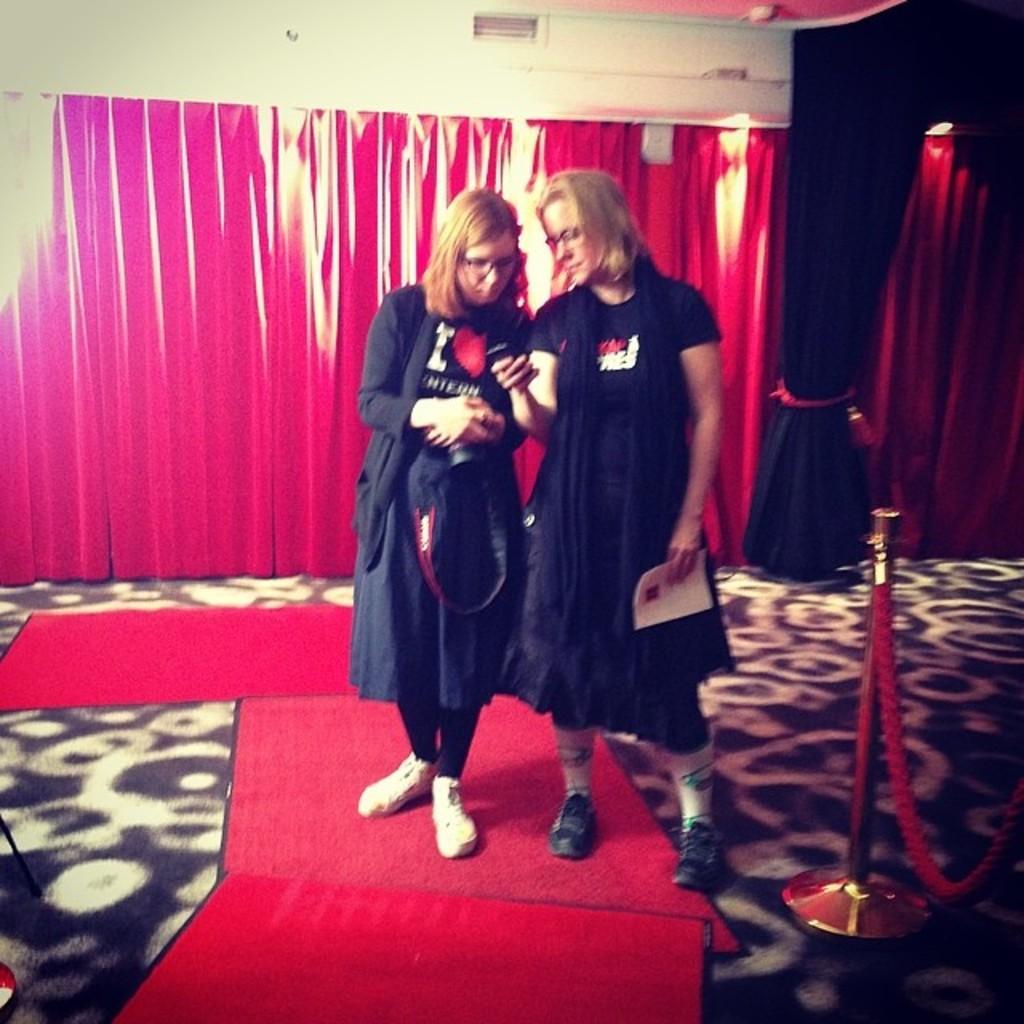In one or two sentences, can you explain what this image depicts? In the image there are two women standing on a carpet and behind them there are curtains. 